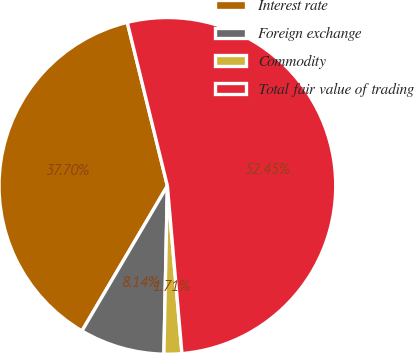<chart> <loc_0><loc_0><loc_500><loc_500><pie_chart><fcel>Interest rate<fcel>Foreign exchange<fcel>Commodity<fcel>Total fair value of trading<nl><fcel>37.7%<fcel>8.14%<fcel>1.71%<fcel>52.45%<nl></chart> 